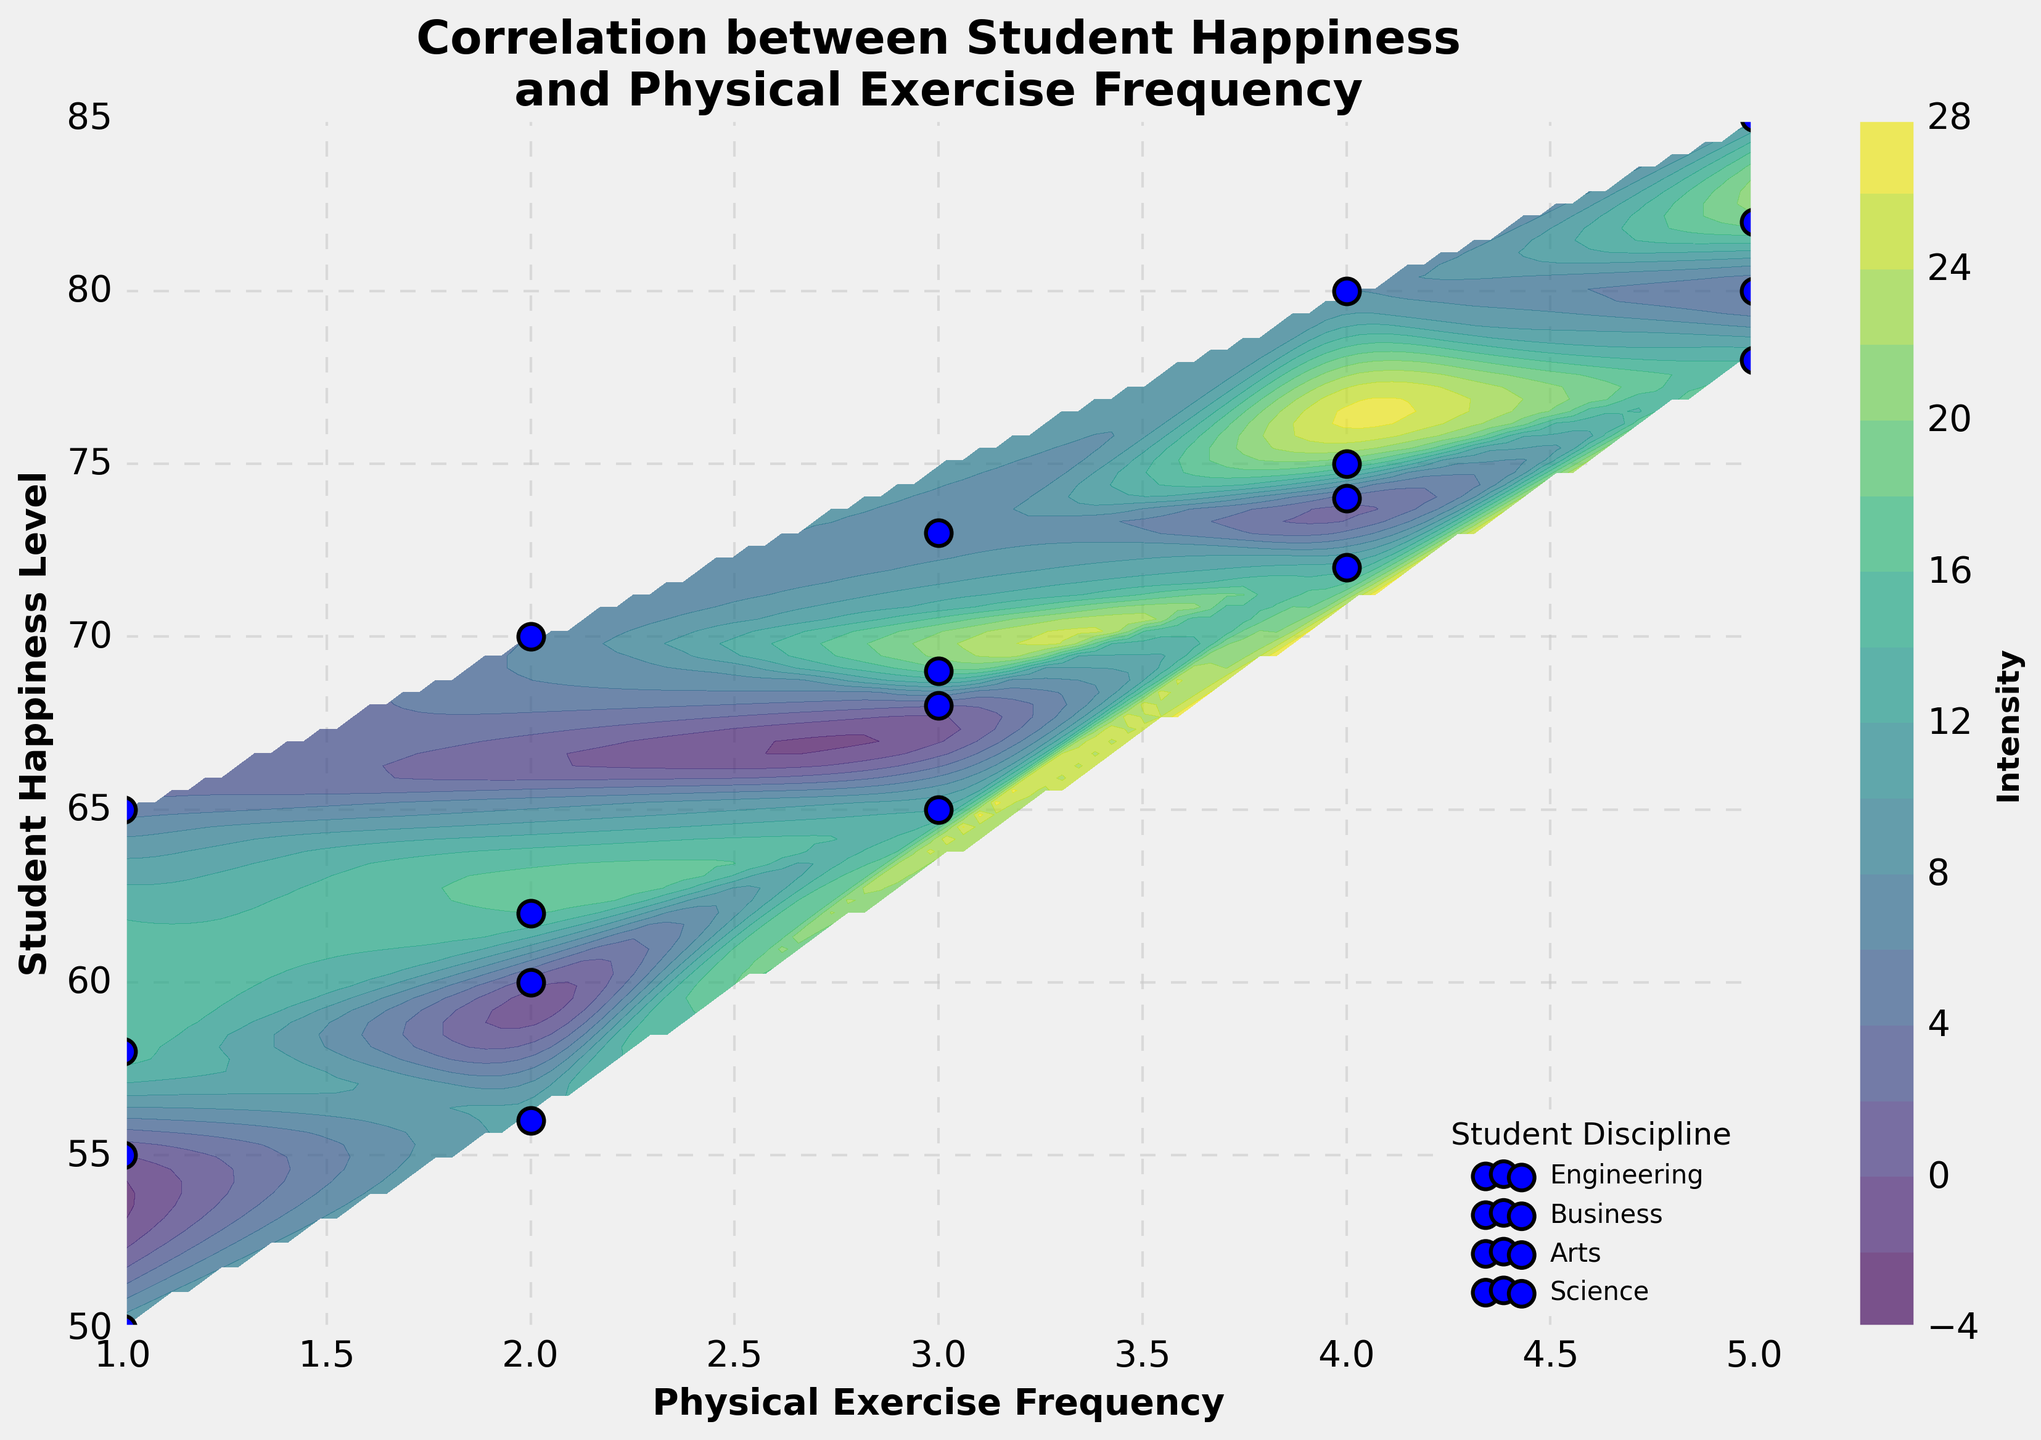What is the title of the figure? The title of the figure is displayed at the top center. It reads "Correlation between Student Happiness and Physical Exercise Frequency".
Answer: Correlation between Student Happiness and Physical Exercise Frequency Which student discipline appears to have the highest individual happiness level? By examining the scatter points and their respective labels, the highest happiness score (85) is in the 'Business' discipline.
Answer: Business What are the x-axis and y-axis labels? The x-axis is labeled "Physical Exercise Frequency" and the y-axis is labeled "Student Happiness Level". This information is present below and to the left of the respective axes.
Answer: Physical Exercise Frequency, Student Happiness Level Which student discipline shows data points with the highest concentration on the contour plot? By looking at the contour density and scatter plot points, the 'Engineering' discipline shows a greater concentration in the mid to higher happiness levels.
Answer: Engineering How does the happiness level change with increasing physical exercise in the Arts discipline? Visually tracing the scatter points for 'Arts', as exercise frequency increases, the happiness level also ascends, specifically from 50 to 78.
Answer: Increases Is there a general trend observed between physical exercise frequency and student happiness levels? From the contour plot and overall scatter points, a positive correlation is observed where an increase in physical exercise frequency corresponds to higher happiness levels.
Answer: Positive correlation At what physical exercise frequency level do most student disciplines overlap in happiness levels? Reviewing the overlapping scatter points and contour density, most disciplines overlap around an exercise frequency of 4 towards higher happiness levels.
Answer: 4 Which disciplines reach a happiness level higher than 80 with frequent physical exercise? Looking at the scatter points individually labeled by discipline, 'Business' and 'Science' have happiness levels surpassing 80 with high exercise frequencies.
Answer: Business, Science Can you identify a discipline that has a relatively lower happiness increase with increasing exercise compared to others? By comparing the scatter point movement for each discipline, 'Arts' shows slower increments in happiness with exercise compared to 'Business' and 'Science'.
Answer: Arts 